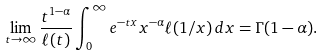<formula> <loc_0><loc_0><loc_500><loc_500>\lim _ { t \rightarrow \infty } \frac { t ^ { 1 - \alpha } } { \ell ( t ) } \int _ { 0 } ^ { \infty } e ^ { - t x } x ^ { - \alpha } \ell ( 1 / x ) \, d x = \Gamma ( 1 - \alpha ) .</formula> 